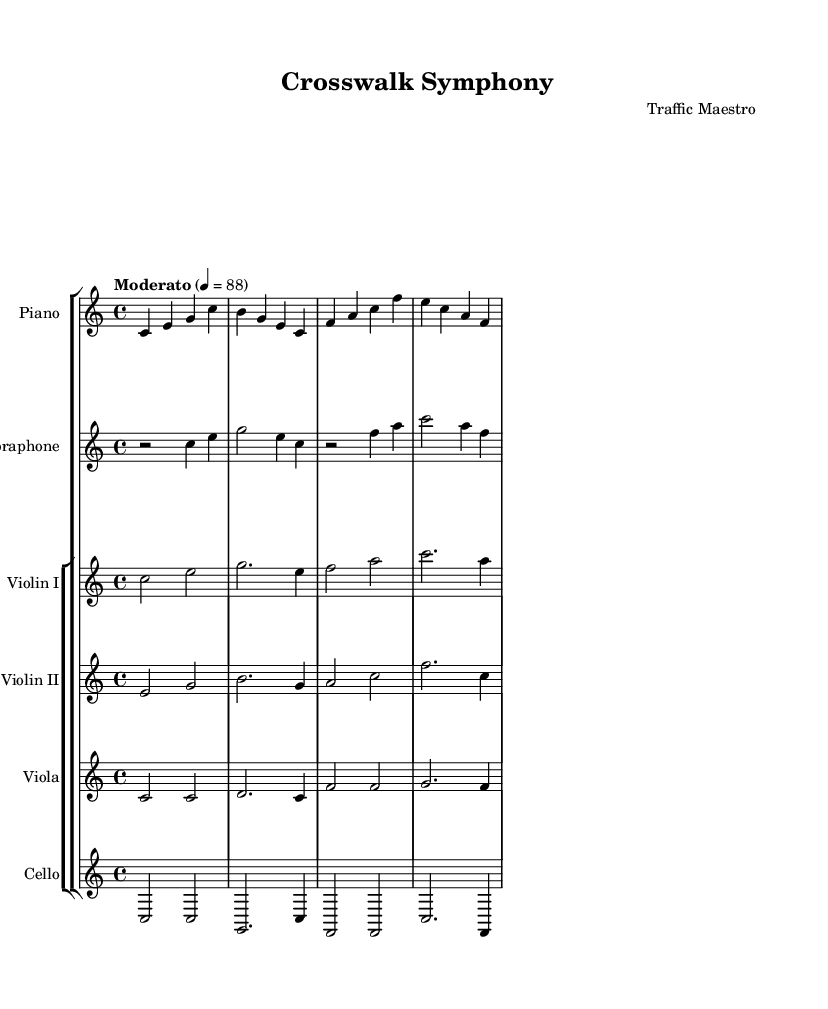What is the key signature of this music? The key signature is indicated at the beginning of the score and shows no sharps or flats, which corresponds to C major.
Answer: C major What is the time signature of this piece? The time signature is located next to the key signature at the start of the score, represented as 4 over 4.
Answer: 4/4 What is the tempo marking for this piece? The tempo marking can be found below the key signature and indicates "Moderato" with a metronome marking of 4 equals 88.
Answer: Moderato How many instruments are featured in this composition? By counting the individual staff lines in the score, the piece has a total of six instruments: Piano, Vibraphone, Violin I, Violin II, Viola, and Cello.
Answer: Six Which instrument plays the highest notes in the score? The highest notes can be determined by comparing the ranges of different instruments; in this score, the Violin I typically plays in the highest register.
Answer: Violin I Are there any rests in the vibraphone part? Checking the vibraphone part in the sheet music reveals that it begins with a rest for two beats at the start before playing.
Answer: Yes 